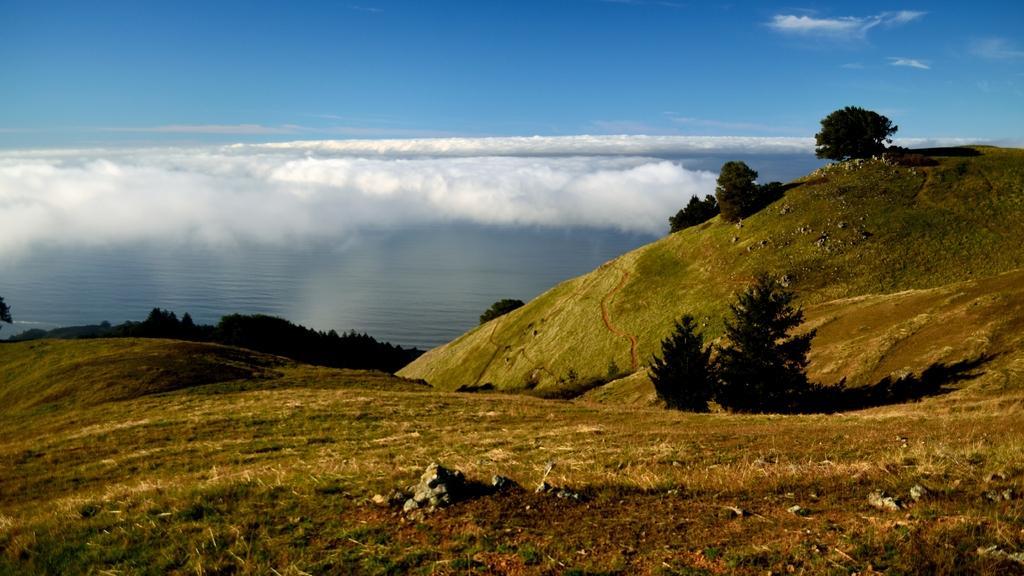How would you summarize this image in a sentence or two? This image is taken outdoors. At the top of the image there is the sky with clouds. At the bottom of the image there is a ground with grass on it. In the middle of the image there is a sea with water. There are a few trees and plants on the ground. 